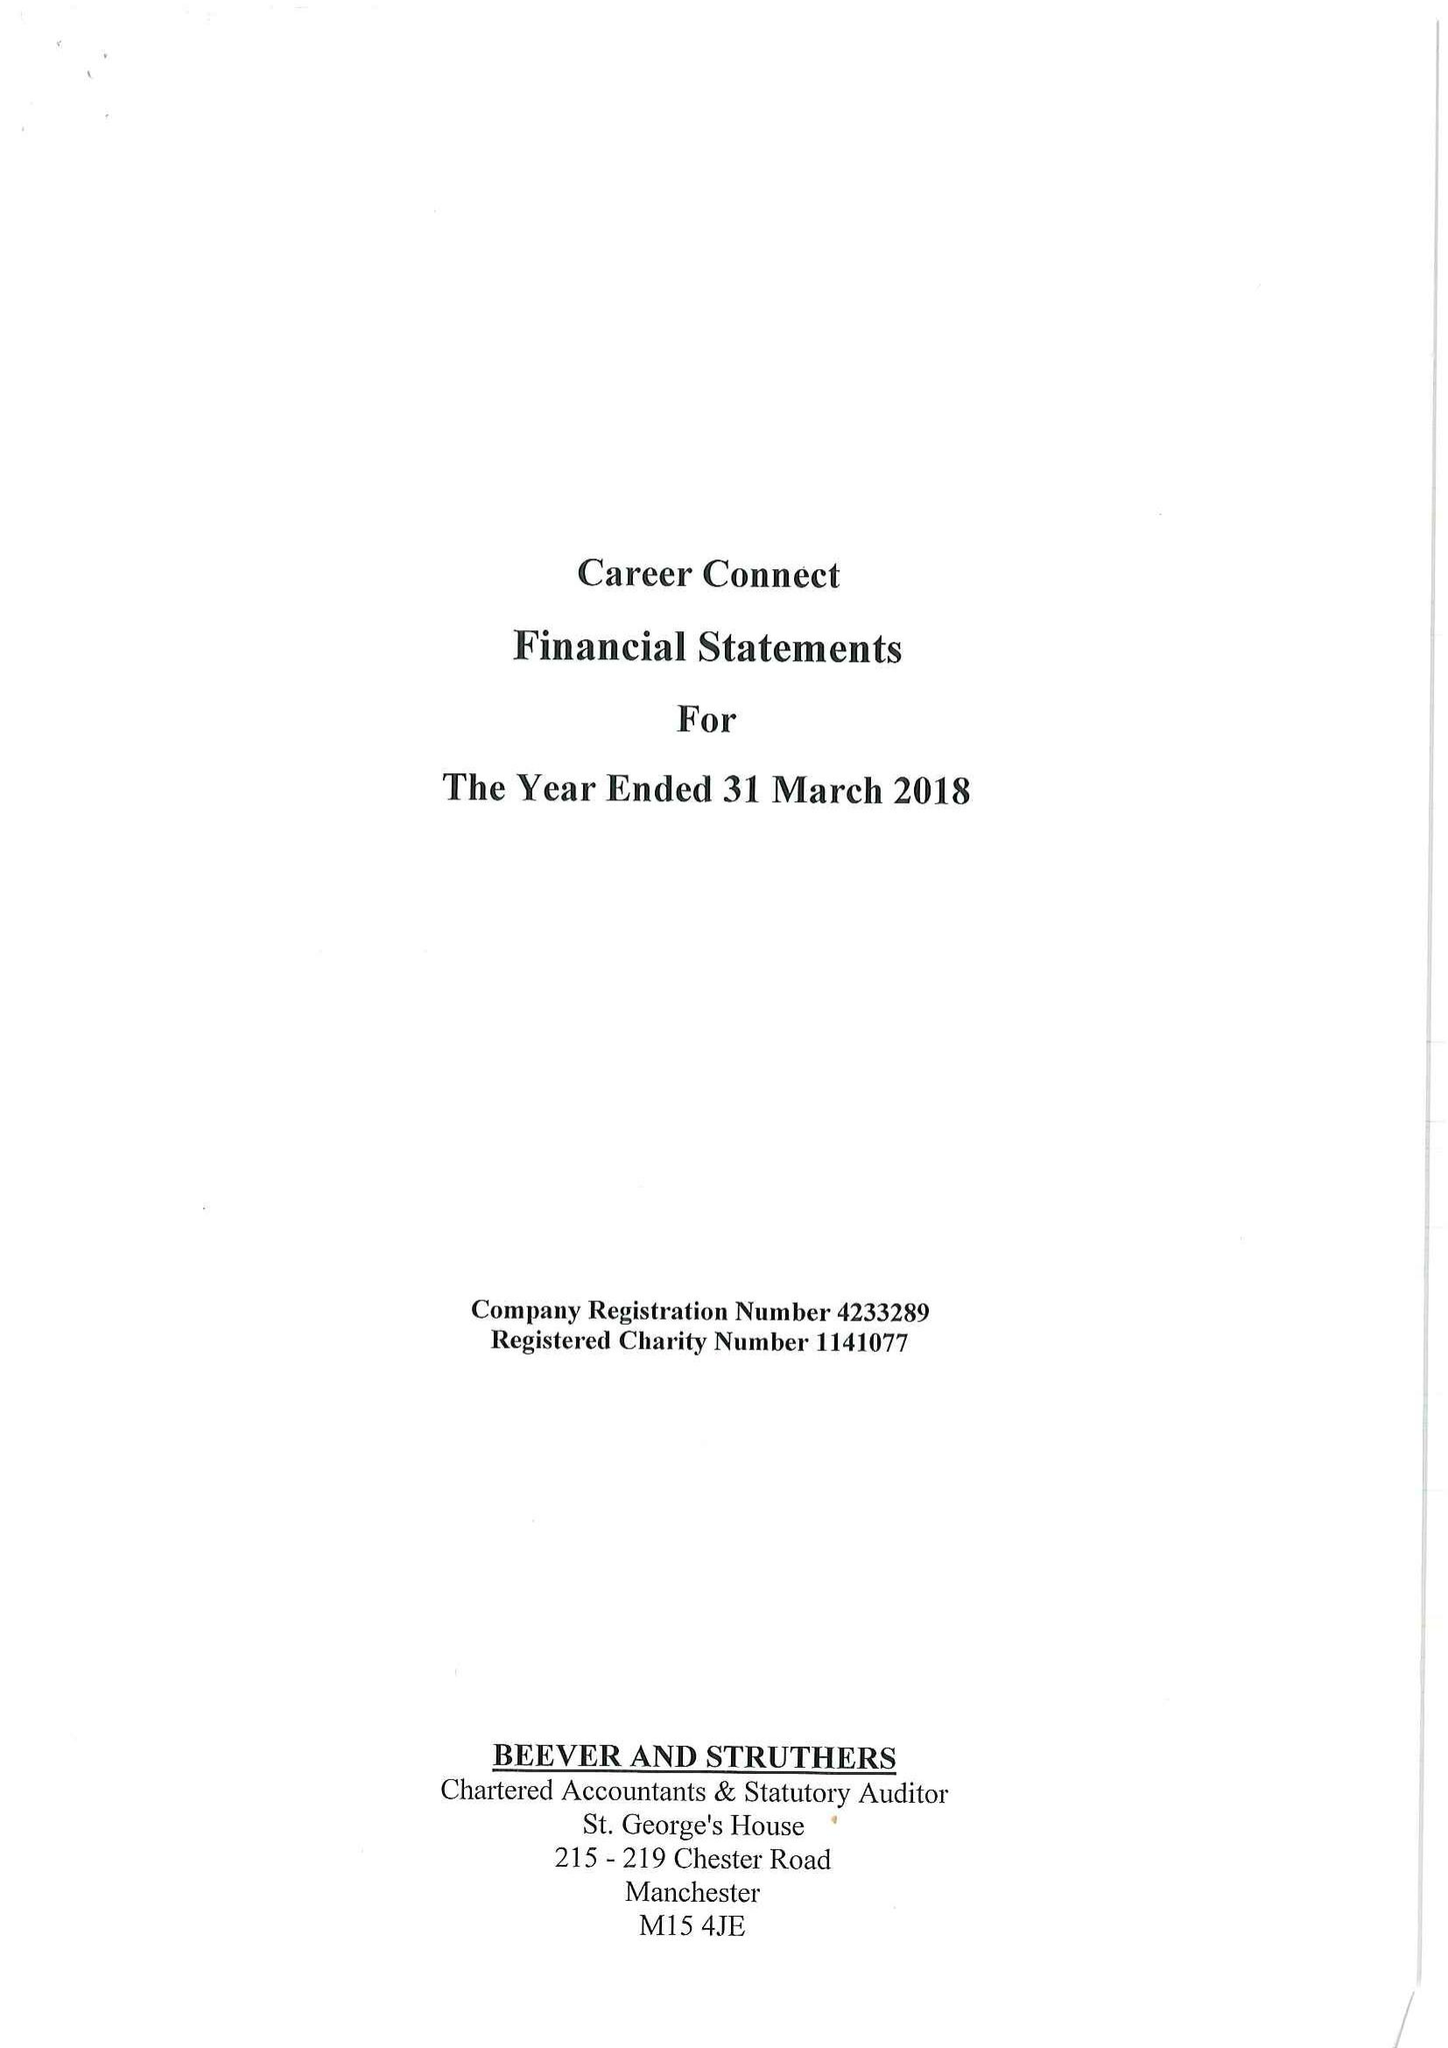What is the value for the address__postcode?
Answer the question using a single word or phrase. L2 3YL 